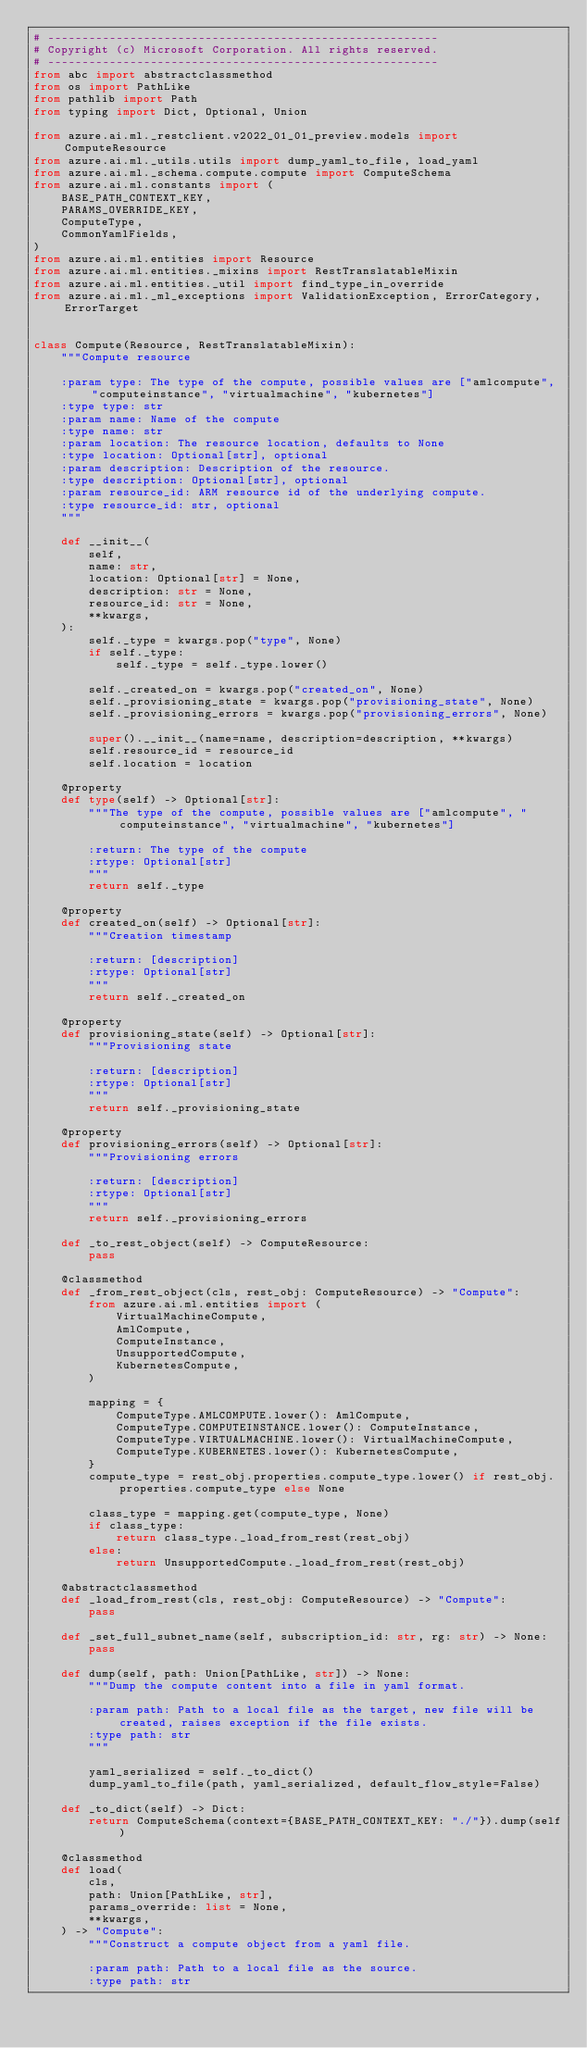Convert code to text. <code><loc_0><loc_0><loc_500><loc_500><_Python_># ---------------------------------------------------------
# Copyright (c) Microsoft Corporation. All rights reserved.
# ---------------------------------------------------------
from abc import abstractclassmethod
from os import PathLike
from pathlib import Path
from typing import Dict, Optional, Union

from azure.ai.ml._restclient.v2022_01_01_preview.models import ComputeResource
from azure.ai.ml._utils.utils import dump_yaml_to_file, load_yaml
from azure.ai.ml._schema.compute.compute import ComputeSchema
from azure.ai.ml.constants import (
    BASE_PATH_CONTEXT_KEY,
    PARAMS_OVERRIDE_KEY,
    ComputeType,
    CommonYamlFields,
)
from azure.ai.ml.entities import Resource
from azure.ai.ml.entities._mixins import RestTranslatableMixin
from azure.ai.ml.entities._util import find_type_in_override
from azure.ai.ml._ml_exceptions import ValidationException, ErrorCategory, ErrorTarget


class Compute(Resource, RestTranslatableMixin):
    """Compute resource

    :param type: The type of the compute, possible values are ["amlcompute", "computeinstance", "virtualmachine", "kubernetes"]
    :type type: str
    :param name: Name of the compute
    :type name: str
    :param location: The resource location, defaults to None
    :type location: Optional[str], optional
    :param description: Description of the resource.
    :type description: Optional[str], optional
    :param resource_id: ARM resource id of the underlying compute.
    :type resource_id: str, optional
    """

    def __init__(
        self,
        name: str,
        location: Optional[str] = None,
        description: str = None,
        resource_id: str = None,
        **kwargs,
    ):
        self._type = kwargs.pop("type", None)
        if self._type:
            self._type = self._type.lower()

        self._created_on = kwargs.pop("created_on", None)
        self._provisioning_state = kwargs.pop("provisioning_state", None)
        self._provisioning_errors = kwargs.pop("provisioning_errors", None)

        super().__init__(name=name, description=description, **kwargs)
        self.resource_id = resource_id
        self.location = location

    @property
    def type(self) -> Optional[str]:
        """The type of the compute, possible values are ["amlcompute", "computeinstance", "virtualmachine", "kubernetes"]

        :return: The type of the compute
        :rtype: Optional[str]
        """
        return self._type

    @property
    def created_on(self) -> Optional[str]:
        """Creation timestamp

        :return: [description]
        :rtype: Optional[str]
        """
        return self._created_on

    @property
    def provisioning_state(self) -> Optional[str]:
        """Provisioning state

        :return: [description]
        :rtype: Optional[str]
        """
        return self._provisioning_state

    @property
    def provisioning_errors(self) -> Optional[str]:
        """Provisioning errors

        :return: [description]
        :rtype: Optional[str]
        """
        return self._provisioning_errors

    def _to_rest_object(self) -> ComputeResource:
        pass

    @classmethod
    def _from_rest_object(cls, rest_obj: ComputeResource) -> "Compute":
        from azure.ai.ml.entities import (
            VirtualMachineCompute,
            AmlCompute,
            ComputeInstance,
            UnsupportedCompute,
            KubernetesCompute,
        )

        mapping = {
            ComputeType.AMLCOMPUTE.lower(): AmlCompute,
            ComputeType.COMPUTEINSTANCE.lower(): ComputeInstance,
            ComputeType.VIRTUALMACHINE.lower(): VirtualMachineCompute,
            ComputeType.KUBERNETES.lower(): KubernetesCompute,
        }
        compute_type = rest_obj.properties.compute_type.lower() if rest_obj.properties.compute_type else None

        class_type = mapping.get(compute_type, None)
        if class_type:
            return class_type._load_from_rest(rest_obj)
        else:
            return UnsupportedCompute._load_from_rest(rest_obj)

    @abstractclassmethod
    def _load_from_rest(cls, rest_obj: ComputeResource) -> "Compute":
        pass

    def _set_full_subnet_name(self, subscription_id: str, rg: str) -> None:
        pass

    def dump(self, path: Union[PathLike, str]) -> None:
        """Dump the compute content into a file in yaml format.

        :param path: Path to a local file as the target, new file will be created, raises exception if the file exists.
        :type path: str
        """

        yaml_serialized = self._to_dict()
        dump_yaml_to_file(path, yaml_serialized, default_flow_style=False)

    def _to_dict(self) -> Dict:
        return ComputeSchema(context={BASE_PATH_CONTEXT_KEY: "./"}).dump(self)

    @classmethod
    def load(
        cls,
        path: Union[PathLike, str],
        params_override: list = None,
        **kwargs,
    ) -> "Compute":
        """Construct a compute object from a yaml file.

        :param path: Path to a local file as the source.
        :type path: str</code> 